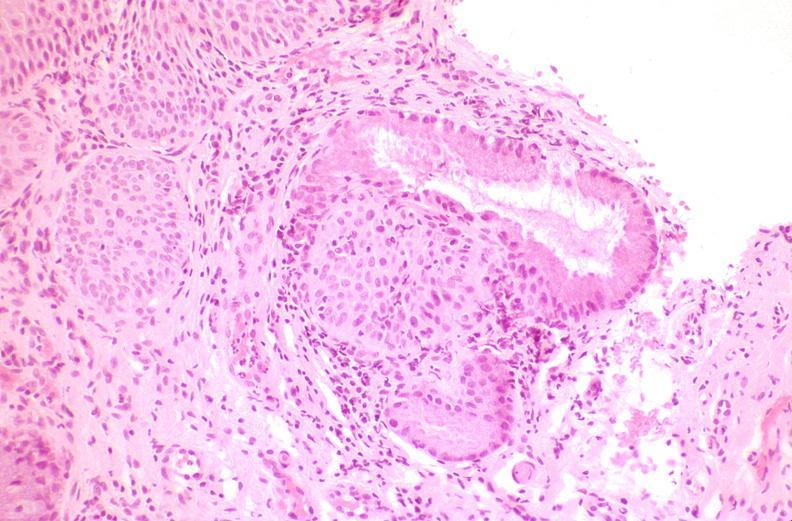s female reproductive present?
Answer the question using a single word or phrase. Yes 